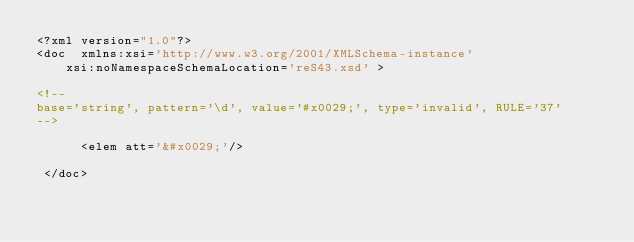Convert code to text. <code><loc_0><loc_0><loc_500><loc_500><_XML_><?xml version="1.0"?>
<doc  xmlns:xsi='http://www.w3.org/2001/XMLSchema-instance'
    xsi:noNamespaceSchemaLocation='reS43.xsd' >

<!-- 
base='string', pattern='\d', value='#x0029;', type='invalid', RULE='37'
-->

      <elem att='&#x0029;'/>

 </doc>
</code> 